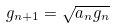<formula> <loc_0><loc_0><loc_500><loc_500>g _ { n + 1 } = { \sqrt { a _ { n } g _ { n } } }</formula> 